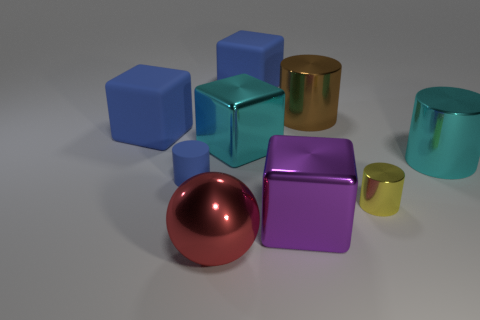Subtract all cyan cylinders. Subtract all gray cubes. How many cylinders are left? 3 Add 1 blocks. How many objects exist? 10 Subtract all cylinders. How many objects are left? 5 Subtract all matte objects. Subtract all big rubber things. How many objects are left? 4 Add 6 yellow shiny things. How many yellow shiny things are left? 7 Add 4 large gray cylinders. How many large gray cylinders exist? 4 Subtract 1 yellow cylinders. How many objects are left? 8 